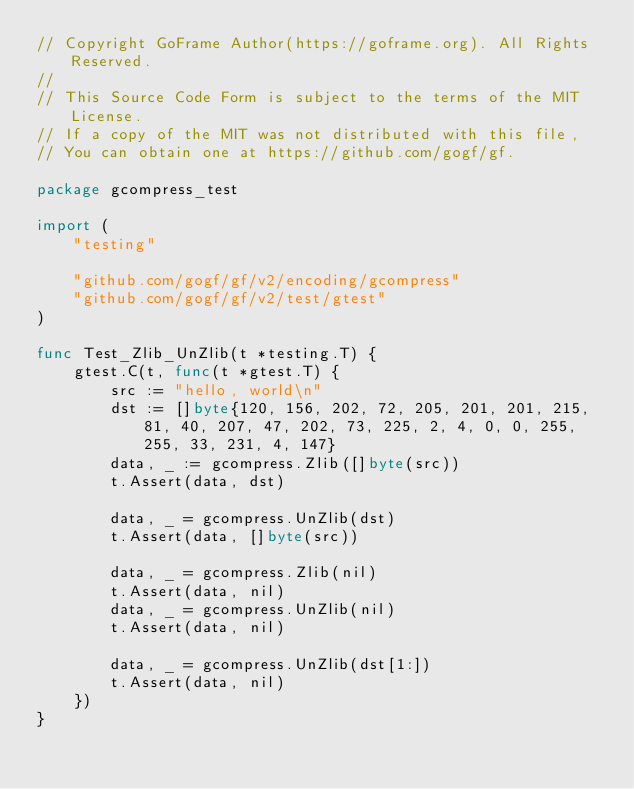Convert code to text. <code><loc_0><loc_0><loc_500><loc_500><_Go_>// Copyright GoFrame Author(https://goframe.org). All Rights Reserved.
//
// This Source Code Form is subject to the terms of the MIT License.
// If a copy of the MIT was not distributed with this file,
// You can obtain one at https://github.com/gogf/gf.

package gcompress_test

import (
	"testing"

	"github.com/gogf/gf/v2/encoding/gcompress"
	"github.com/gogf/gf/v2/test/gtest"
)

func Test_Zlib_UnZlib(t *testing.T) {
	gtest.C(t, func(t *gtest.T) {
		src := "hello, world\n"
		dst := []byte{120, 156, 202, 72, 205, 201, 201, 215, 81, 40, 207, 47, 202, 73, 225, 2, 4, 0, 0, 255, 255, 33, 231, 4, 147}
		data, _ := gcompress.Zlib([]byte(src))
		t.Assert(data, dst)

		data, _ = gcompress.UnZlib(dst)
		t.Assert(data, []byte(src))

		data, _ = gcompress.Zlib(nil)
		t.Assert(data, nil)
		data, _ = gcompress.UnZlib(nil)
		t.Assert(data, nil)

		data, _ = gcompress.UnZlib(dst[1:])
		t.Assert(data, nil)
	})
}
</code> 